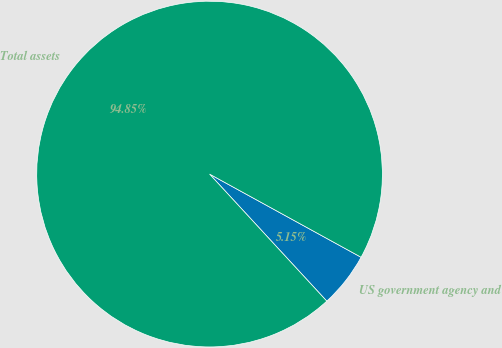Convert chart. <chart><loc_0><loc_0><loc_500><loc_500><pie_chart><fcel>US government agency and<fcel>Total assets<nl><fcel>5.15%<fcel>94.85%<nl></chart> 